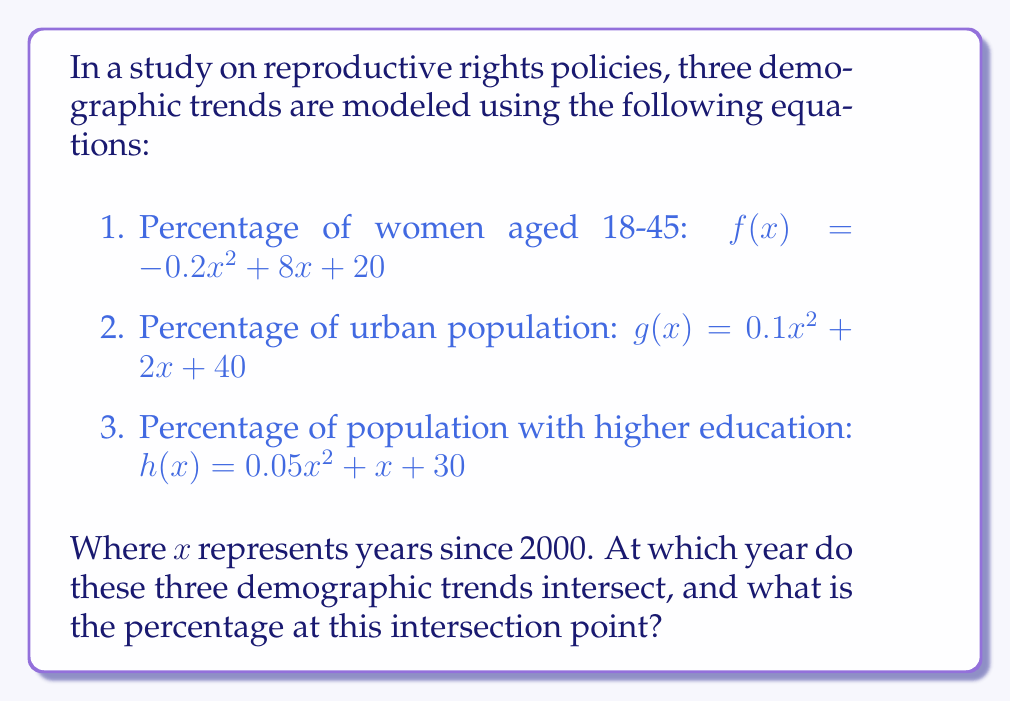Can you solve this math problem? To find the intersection point of these three trends, we need to solve the system of equations:

$$
\begin{cases}
-0.2x^2 + 8x + 20 = y \\
0.1x^2 + 2x + 40 = y \\
0.05x^2 + x + 30 = y
\end{cases}
$$

Step 1: Equate $f(x)$ and $g(x)$:
$$-0.2x^2 + 8x + 20 = 0.1x^2 + 2x + 40$$
$$-0.3x^2 + 6x - 20 = 0$$

Step 2: Equate $f(x)$ and $h(x)$:
$$-0.2x^2 + 8x + 20 = 0.05x^2 + x + 30$$
$$-0.25x^2 + 7x - 10 = 0$$

Step 3: Solve the quadratic equation from Step 1:
$$x = \frac{-6 \pm \sqrt{36 + 24}}{-0.6} = \frac{-6 \pm \sqrt{60}}{-0.6}$$
$$x \approx 15.27 \text{ or } x \approx -5.27$$

Step 4: Solve the quadratic equation from Step 2:
$$x = \frac{-7 \pm \sqrt{49 + 10}}{-0.5} = \frac{-7 \pm \sqrt{59}}{-0.5}$$
$$x \approx 15.37 \text{ or } x \approx -1.37$$

Step 5: The common solution is approximately $x = 15.3$ (rounded to one decimal place).

Step 6: Calculate the percentage at the intersection point by substituting $x = 15.3$ into any of the original equations:

$$f(15.3) = -0.2(15.3)^2 + 8(15.3) + 20 \approx 65.8\%$$

Therefore, the three demographic trends intersect approximately 15.3 years after 2000 (i.e., in 2015) at about 65.8%.
Answer: Year 2015; 65.8% 